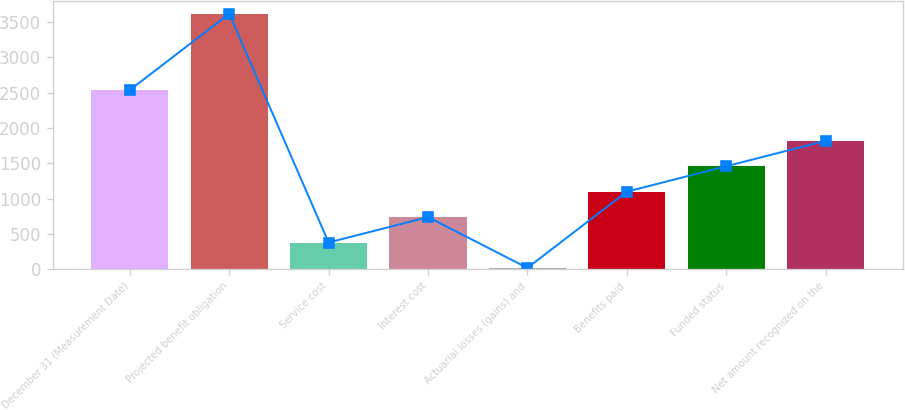Convert chart to OTSL. <chart><loc_0><loc_0><loc_500><loc_500><bar_chart><fcel>December 31 (Measurement Date)<fcel>Projected benefit obligation<fcel>Service cost<fcel>Interest cost<fcel>Actuarial losses (gains) and<fcel>Benefits paid<fcel>Funded status<fcel>Net amount recognized on the<nl><fcel>2537.3<fcel>3617<fcel>377.9<fcel>737.8<fcel>18<fcel>1097.7<fcel>1457.6<fcel>1817.5<nl></chart> 